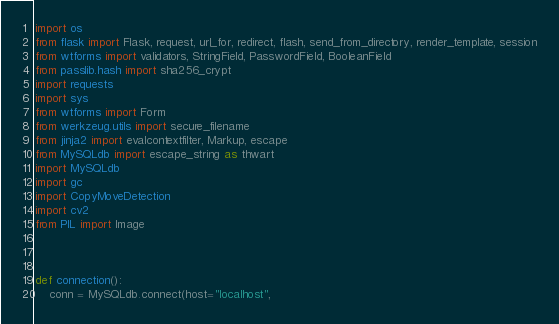<code> <loc_0><loc_0><loc_500><loc_500><_Python_>import os
from flask import Flask, request, url_for, redirect, flash, send_from_directory, render_template, session
from wtforms import validators, StringField, PasswordField, BooleanField
from passlib.hash import sha256_crypt
import requests
import sys
from wtforms import Form
from werkzeug.utils import secure_filename
from jinja2 import evalcontextfilter, Markup, escape
from MySQLdb import escape_string as thwart
import MySQLdb
import gc
import CopyMoveDetection
import cv2
from PIL import Image



def connection():
    conn = MySQLdb.connect(host="localhost",</code> 